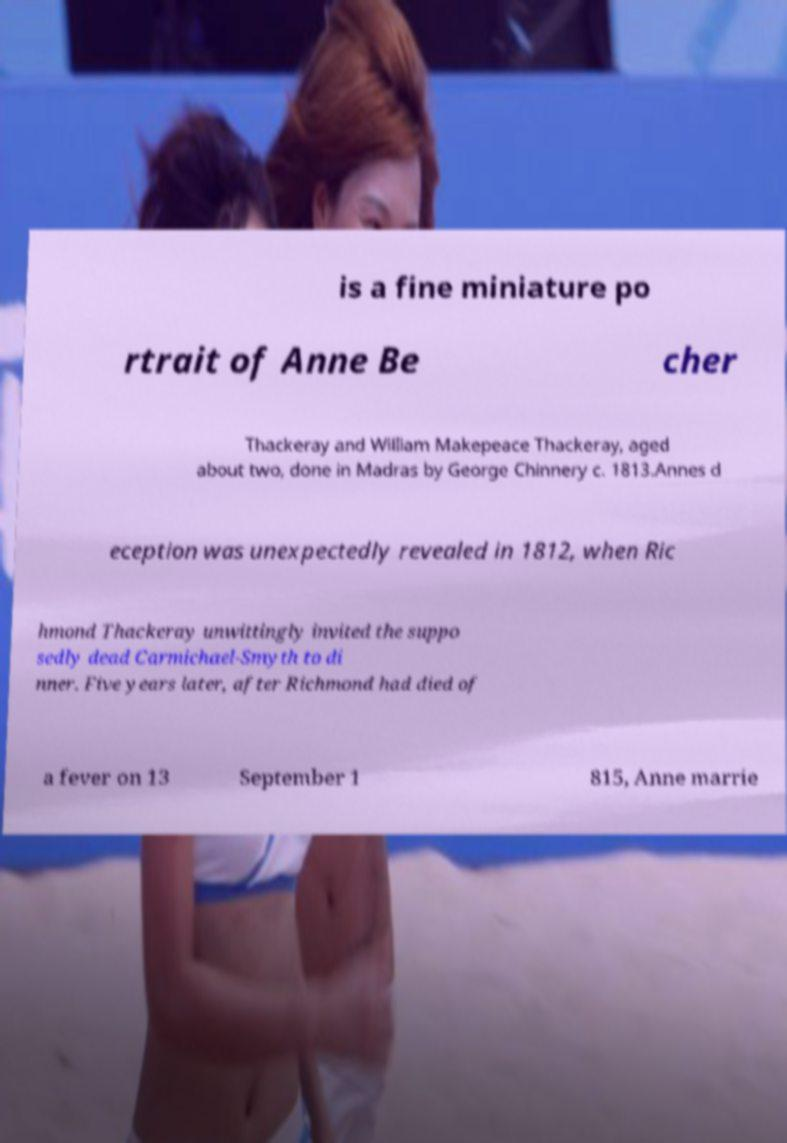For documentation purposes, I need the text within this image transcribed. Could you provide that? is a fine miniature po rtrait of Anne Be cher Thackeray and William Makepeace Thackeray, aged about two, done in Madras by George Chinnery c. 1813.Annes d eception was unexpectedly revealed in 1812, when Ric hmond Thackeray unwittingly invited the suppo sedly dead Carmichael-Smyth to di nner. Five years later, after Richmond had died of a fever on 13 September 1 815, Anne marrie 